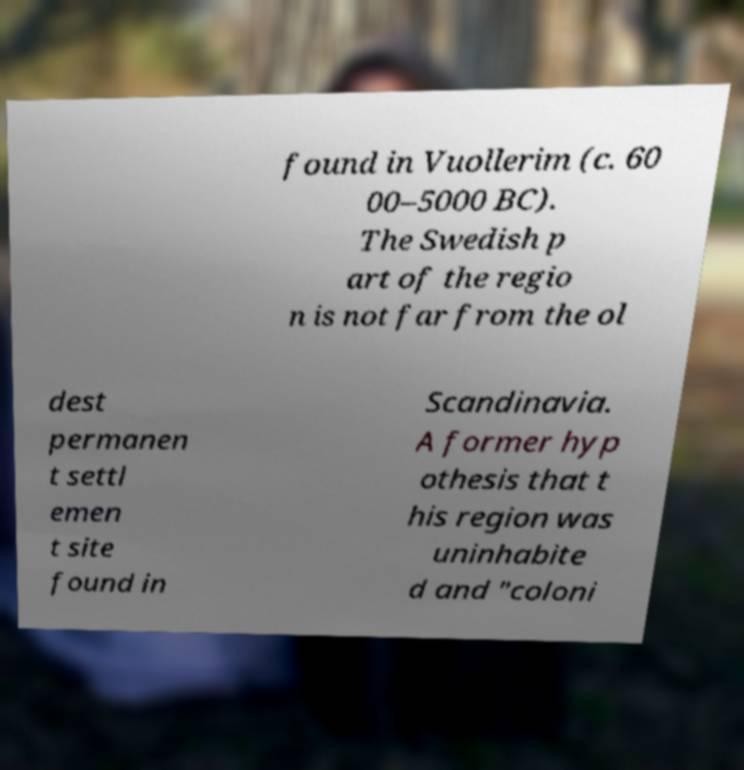Can you read and provide the text displayed in the image?This photo seems to have some interesting text. Can you extract and type it out for me? found in Vuollerim (c. 60 00–5000 BC). The Swedish p art of the regio n is not far from the ol dest permanen t settl emen t site found in Scandinavia. A former hyp othesis that t his region was uninhabite d and "coloni 